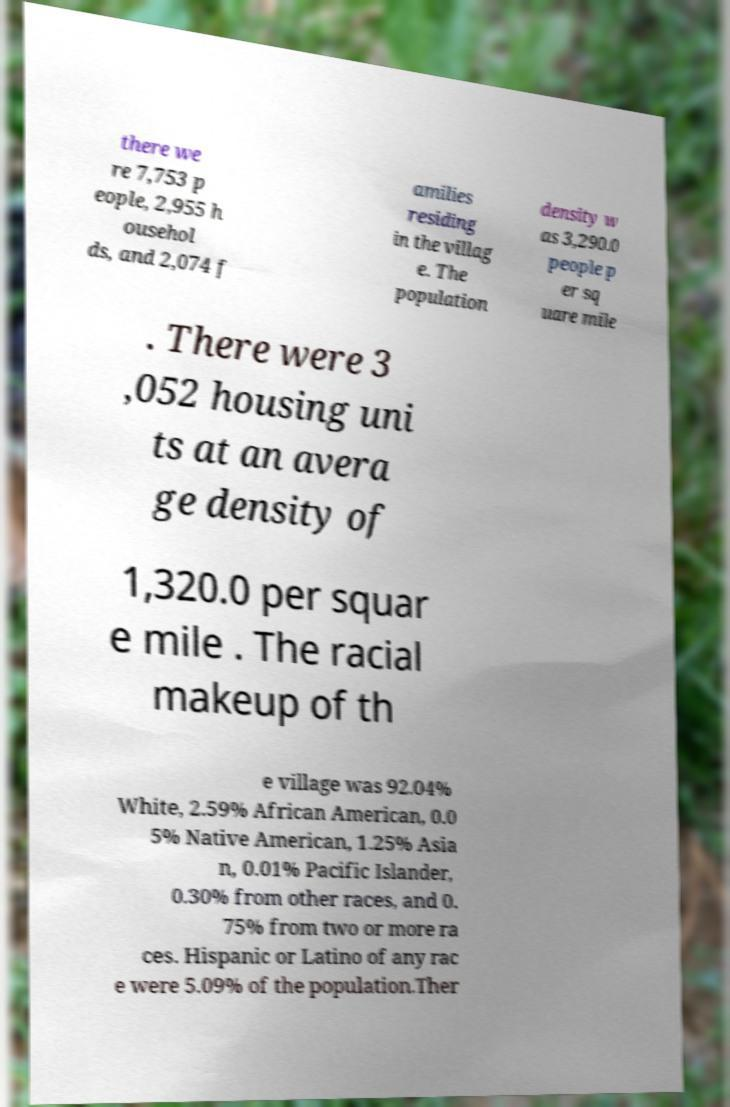I need the written content from this picture converted into text. Can you do that? there we re 7,753 p eople, 2,955 h ousehol ds, and 2,074 f amilies residing in the villag e. The population density w as 3,290.0 people p er sq uare mile . There were 3 ,052 housing uni ts at an avera ge density of 1,320.0 per squar e mile . The racial makeup of th e village was 92.04% White, 2.59% African American, 0.0 5% Native American, 1.25% Asia n, 0.01% Pacific Islander, 0.30% from other races, and 0. 75% from two or more ra ces. Hispanic or Latino of any rac e were 5.09% of the population.Ther 